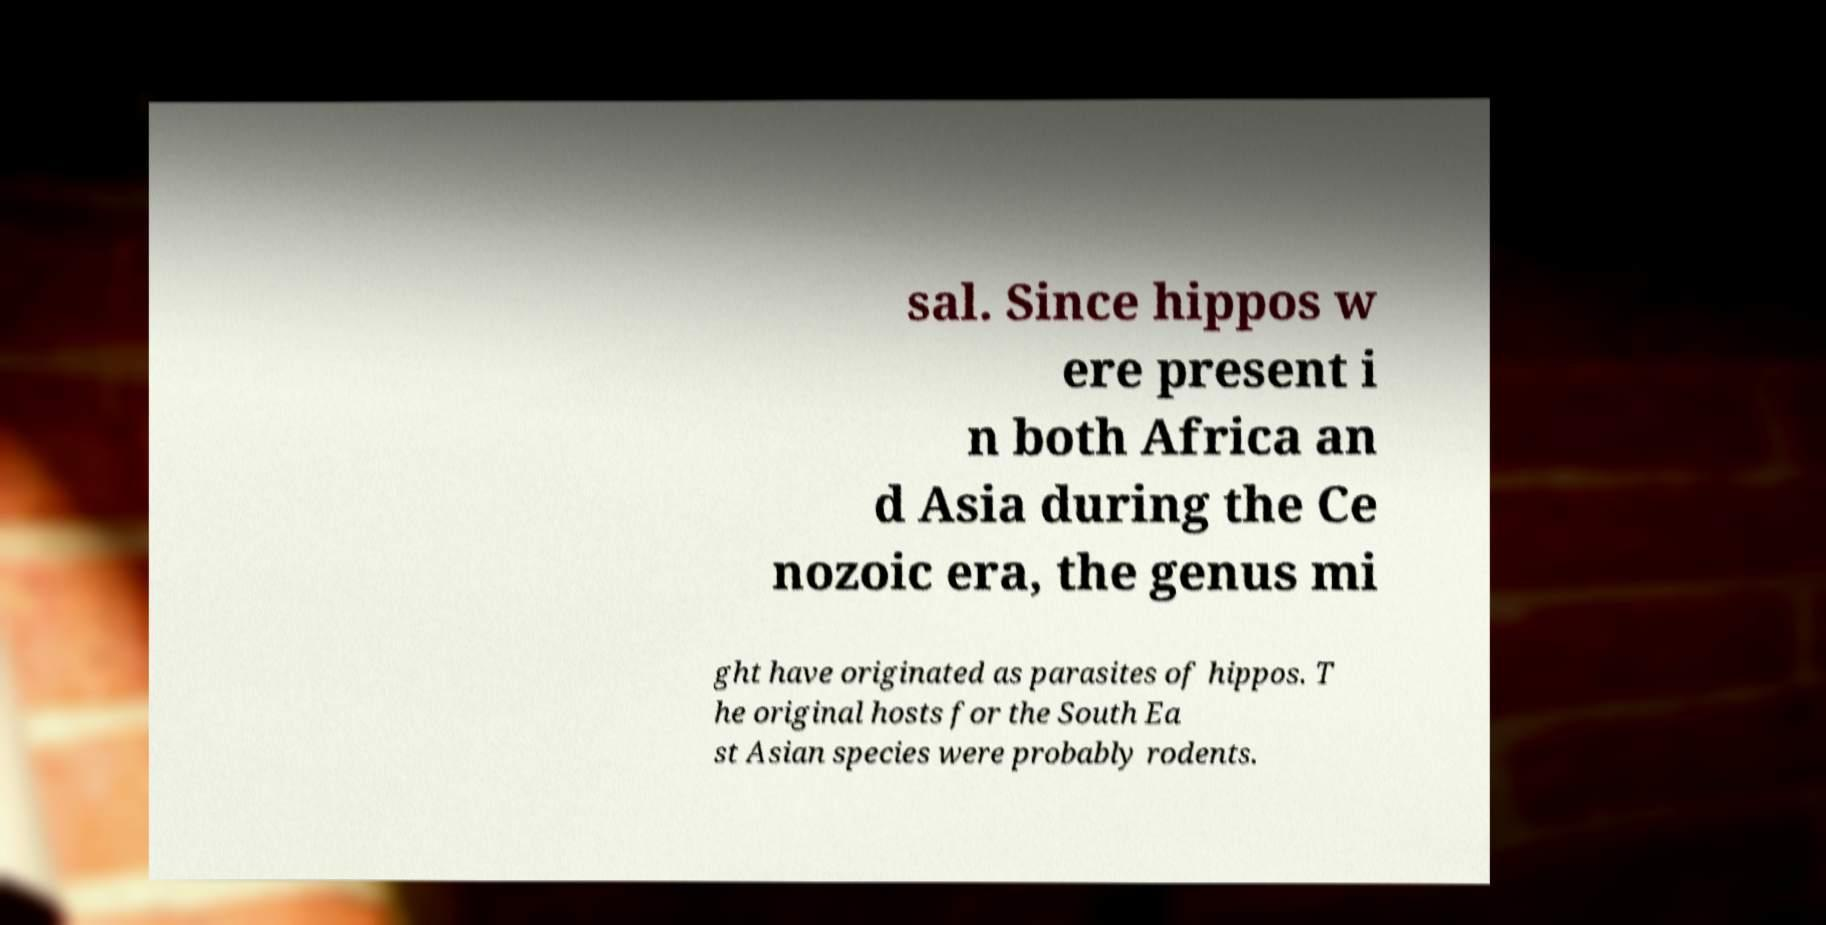For documentation purposes, I need the text within this image transcribed. Could you provide that? sal. Since hippos w ere present i n both Africa an d Asia during the Ce nozoic era, the genus mi ght have originated as parasites of hippos. T he original hosts for the South Ea st Asian species were probably rodents. 